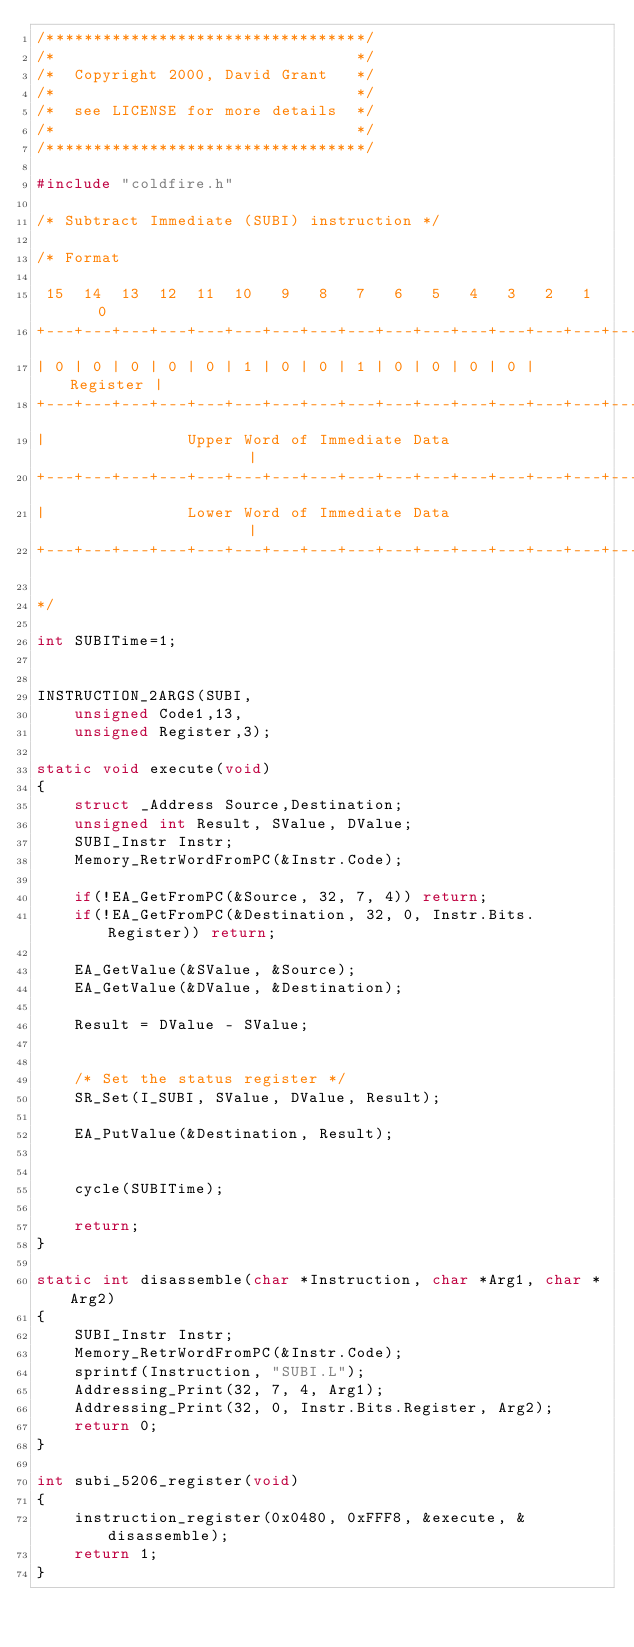Convert code to text. <code><loc_0><loc_0><loc_500><loc_500><_C_>/**********************************/
/*                                */
/*  Copyright 2000, David Grant   */
/*                                */
/*  see LICENSE for more details  */
/*                                */
/**********************************/

#include "coldfire.h"

/* Subtract Immediate (SUBI) instruction */

/* Format 
   
 15  14  13  12  11  10   9   8   7   6   5   4   3   2   1   0
+---+---+---+---+---+---+---+---+---+---+---+---+---+---+---+---+
| 0 | 0 | 0 | 0 | 0 | 1 | 0 | 0 | 1 | 0 | 0 | 0 | 0 |  Register |
+---+---+---+---+---+---+---+---+---+---+---+---+---+---+---+---+
|               Upper Word of Immediate Data                    |
+---+---+---+---+---+---+---+---+---+---+---+---+---+---+---+---+
|               Lower Word of Immediate Data                    |
+---+---+---+---+---+---+---+---+---+---+---+---+---+---+---+---+

*/

int SUBITime=1;


INSTRUCTION_2ARGS(SUBI,
	unsigned Code1,13,
	unsigned Register,3);

static void execute(void)
{
	struct _Address Source,Destination;
	unsigned int Result, SValue, DValue;
	SUBI_Instr Instr;
	Memory_RetrWordFromPC(&Instr.Code);

	if(!EA_GetFromPC(&Source, 32, 7, 4)) return;
	if(!EA_GetFromPC(&Destination, 32, 0, Instr.Bits.Register)) return;

	EA_GetValue(&SValue, &Source);
	EA_GetValue(&DValue, &Destination);

	Result = DValue - SValue;


	/* Set the status register */
	SR_Set(I_SUBI, SValue, DValue, Result);

	EA_PutValue(&Destination, Result);


	cycle(SUBITime);
	
	return;
}

static int disassemble(char *Instruction, char *Arg1, char *Arg2)
{
	SUBI_Instr Instr;
	Memory_RetrWordFromPC(&Instr.Code);
	sprintf(Instruction, "SUBI.L");
	Addressing_Print(32, 7, 4, Arg1);
	Addressing_Print(32, 0, Instr.Bits.Register, Arg2);
	return 0;
}

int subi_5206_register(void)
{
	instruction_register(0x0480, 0xFFF8, &execute, &disassemble);
	return 1;
}
</code> 